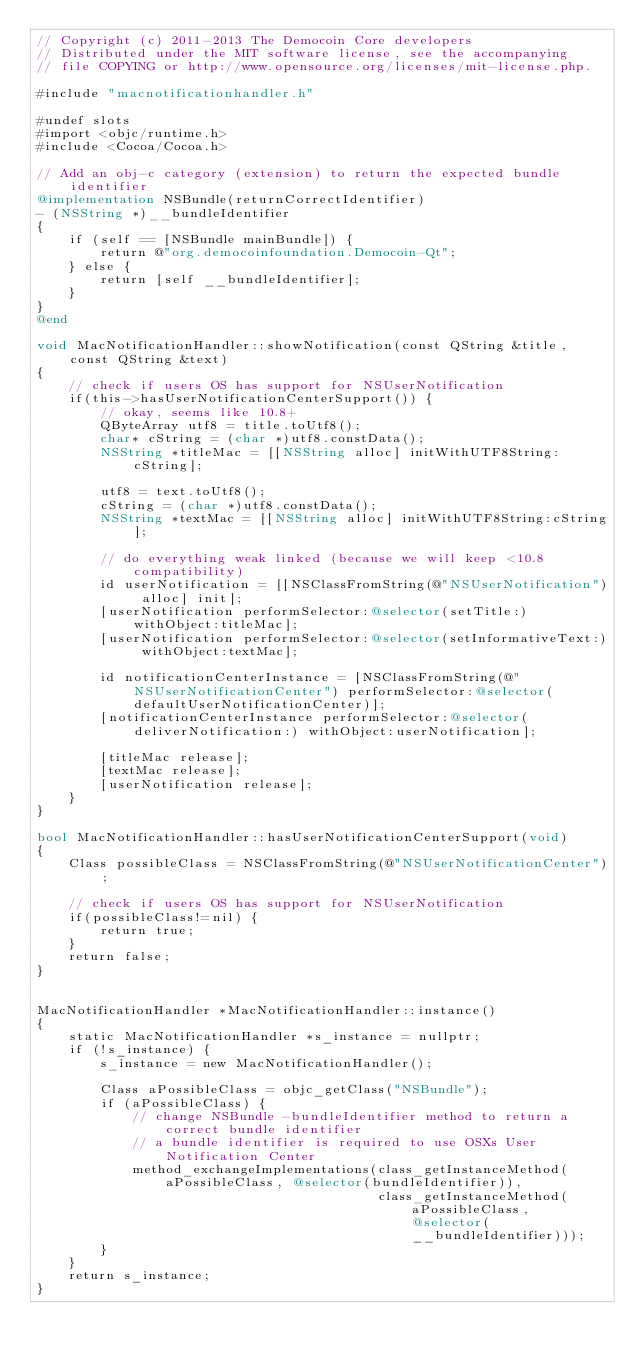<code> <loc_0><loc_0><loc_500><loc_500><_ObjectiveC_>// Copyright (c) 2011-2013 The Democoin Core developers
// Distributed under the MIT software license, see the accompanying
// file COPYING or http://www.opensource.org/licenses/mit-license.php.

#include "macnotificationhandler.h"

#undef slots
#import <objc/runtime.h>
#include <Cocoa/Cocoa.h>

// Add an obj-c category (extension) to return the expected bundle identifier
@implementation NSBundle(returnCorrectIdentifier)
- (NSString *)__bundleIdentifier
{
    if (self == [NSBundle mainBundle]) {
        return @"org.democoinfoundation.Democoin-Qt";
    } else {
        return [self __bundleIdentifier];
    }
}
@end

void MacNotificationHandler::showNotification(const QString &title, const QString &text)
{
    // check if users OS has support for NSUserNotification
    if(this->hasUserNotificationCenterSupport()) {
        // okay, seems like 10.8+
        QByteArray utf8 = title.toUtf8();
        char* cString = (char *)utf8.constData();
        NSString *titleMac = [[NSString alloc] initWithUTF8String:cString];

        utf8 = text.toUtf8();
        cString = (char *)utf8.constData();
        NSString *textMac = [[NSString alloc] initWithUTF8String:cString];

        // do everything weak linked (because we will keep <10.8 compatibility)
        id userNotification = [[NSClassFromString(@"NSUserNotification") alloc] init];
        [userNotification performSelector:@selector(setTitle:) withObject:titleMac];
        [userNotification performSelector:@selector(setInformativeText:) withObject:textMac];

        id notificationCenterInstance = [NSClassFromString(@"NSUserNotificationCenter") performSelector:@selector(defaultUserNotificationCenter)];
        [notificationCenterInstance performSelector:@selector(deliverNotification:) withObject:userNotification];

        [titleMac release];
        [textMac release];
        [userNotification release];
    }
}

bool MacNotificationHandler::hasUserNotificationCenterSupport(void)
{
    Class possibleClass = NSClassFromString(@"NSUserNotificationCenter");

    // check if users OS has support for NSUserNotification
    if(possibleClass!=nil) {
        return true;
    }
    return false;
}


MacNotificationHandler *MacNotificationHandler::instance()
{
    static MacNotificationHandler *s_instance = nullptr;
    if (!s_instance) {
        s_instance = new MacNotificationHandler();

        Class aPossibleClass = objc_getClass("NSBundle");
        if (aPossibleClass) {
            // change NSBundle -bundleIdentifier method to return a correct bundle identifier
            // a bundle identifier is required to use OSXs User Notification Center
            method_exchangeImplementations(class_getInstanceMethod(aPossibleClass, @selector(bundleIdentifier)),
                                           class_getInstanceMethod(aPossibleClass, @selector(__bundleIdentifier)));
        }
    }
    return s_instance;
}
</code> 